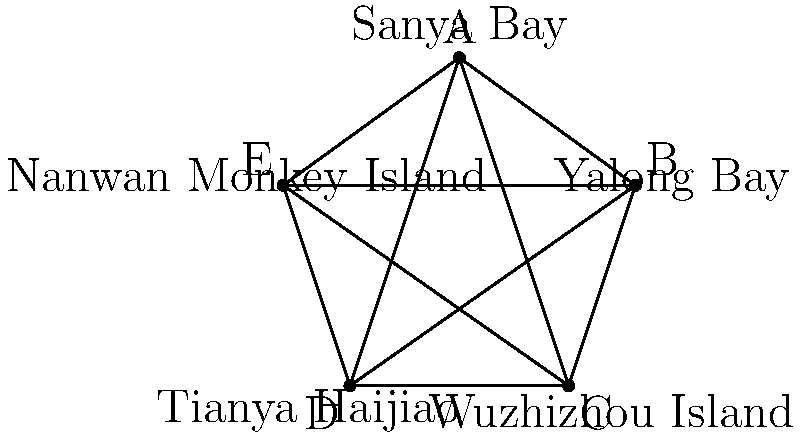In a popular Chinese reality TV show filmed in Hainan, contestants visit five famous landmarks: Sanya Bay, Yalong Bay, Wuzhizhou Island, Tianya Haijiao, and Nanwan Monkey Island. When connected on a map, these landmarks form a star-shaped polygon as shown. What is the sum of the internal angles of this star-shaped polygon? Let's approach this step-by-step:

1) First, we need to recognize that this star-shaped polygon is formed by connecting every second point of a regular pentagon.

2) In a regular pentagon, each internal angle measures $(540°/5) = 108°$.

3) The star polygon has 5 points, so it consists of 5 triangles.

4) In each of these triangles, we know two angles:
   - The angle at the center of the star, which is $180° - 108° = 72°$ (supplementary to the pentagon's internal angle)
   - The angle at the point of the star, which is $36°$ (half of the $72°$ angle, as the star point bisects it)

5) Since the sum of angles in a triangle is $180°$, the third angle in each triangle must be:
   $180° - 72° - 36° = 72°$

6) This $72°$ angle is the internal angle of our star polygon at each point.

7) There are 5 such angles in the star polygon.

8) Therefore, the sum of the internal angles is $5 * 72° = 360°$

This result is consistent with the theorem that states the sum of internal angles of any 5-pointed star polygon is always $360°$.
Answer: $360°$ 